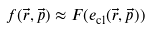Convert formula to latex. <formula><loc_0><loc_0><loc_500><loc_500>f ( \vec { r } , \vec { p } ) \approx F ( e _ { \text {cl} } ( \vec { r } , \vec { p } ) )</formula> 